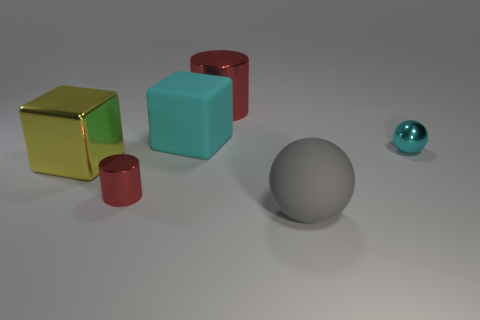There is a cyan object that is to the left of the big red object; what shape is it?
Ensure brevity in your answer.  Cube. The matte ball has what color?
Your answer should be compact. Gray. What color is the large cube that is the same material as the big ball?
Offer a very short reply. Cyan. How many spheres are the same material as the large red object?
Ensure brevity in your answer.  1. There is a cyan rubber object; how many metal cylinders are behind it?
Keep it short and to the point. 1. Is the big gray sphere that is in front of the cyan shiny object made of the same material as the ball that is to the right of the gray ball?
Ensure brevity in your answer.  No. Is the number of tiny cyan spheres that are on the left side of the yellow cube greater than the number of large red cylinders that are on the right side of the large red cylinder?
Your answer should be compact. No. There is a tiny object that is the same color as the large matte cube; what is it made of?
Provide a short and direct response. Metal. There is a large object that is both in front of the large rubber cube and on the right side of the big yellow metallic block; what is its material?
Make the answer very short. Rubber. Are the cyan block and the cylinder that is in front of the big yellow metal block made of the same material?
Keep it short and to the point. No. 